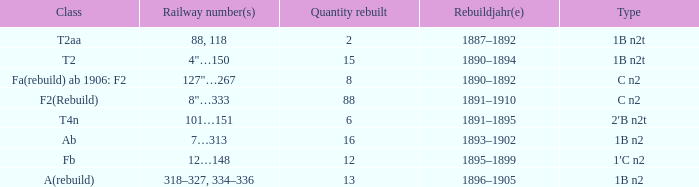What was the Rebuildjahr(e) for the T2AA class? 1887–1892. Parse the table in full. {'header': ['Class', 'Railway number(s)', 'Quantity rebuilt', 'Rebuildjahr(e)', 'Type'], 'rows': [['T2aa', '88, 118', '2', '1887–1892', '1B n2t'], ['T2', '4"…150', '15', '1890–1894', '1B n2t'], ['Fa(rebuild) ab 1906: F2', '127"…267', '8', '1890–1892', 'C n2'], ['F2(Rebuild)', '8"…333', '88', '1891–1910', 'C n2'], ['T4n', '101…151', '6', '1891–1895', '2′B n2t'], ['Ab', '7…313', '16', '1893–1902', '1B n2'], ['Fb', '12…148', '12', '1895–1899', '1′C n2'], ['A(rebuild)', '318–327, 334–336', '13', '1896–1905', '1B n2']]} 